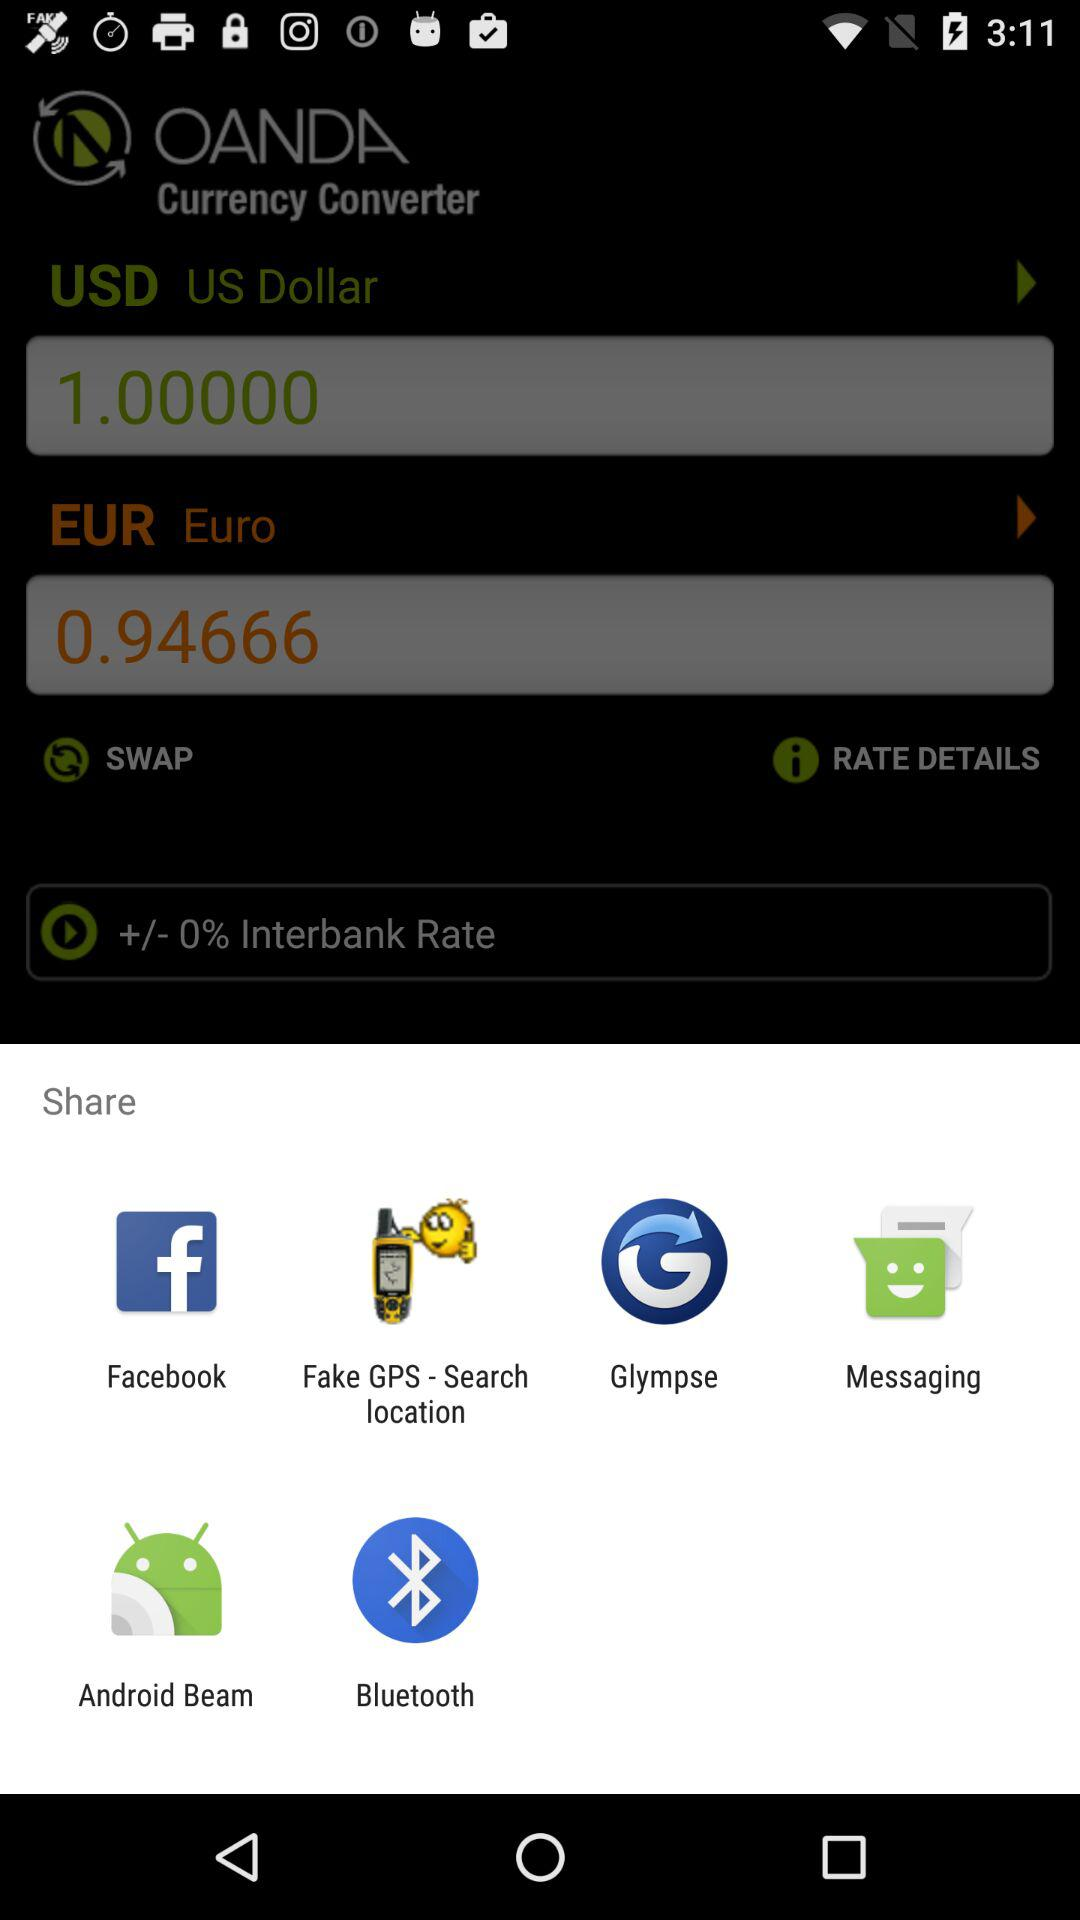What is the amount in USD? The amount is 1 USD. 